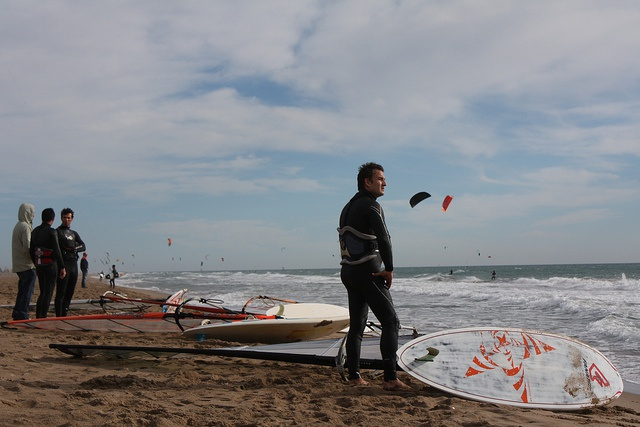Describe the objects in this image and their specific colors. I can see surfboard in darkgray, lightgray, and gray tones, people in darkgray, black, gray, and maroon tones, boat in darkgray, black, lightgray, and maroon tones, surfboard in darkgray, black, and maroon tones, and people in darkgray, black, and gray tones in this image. 